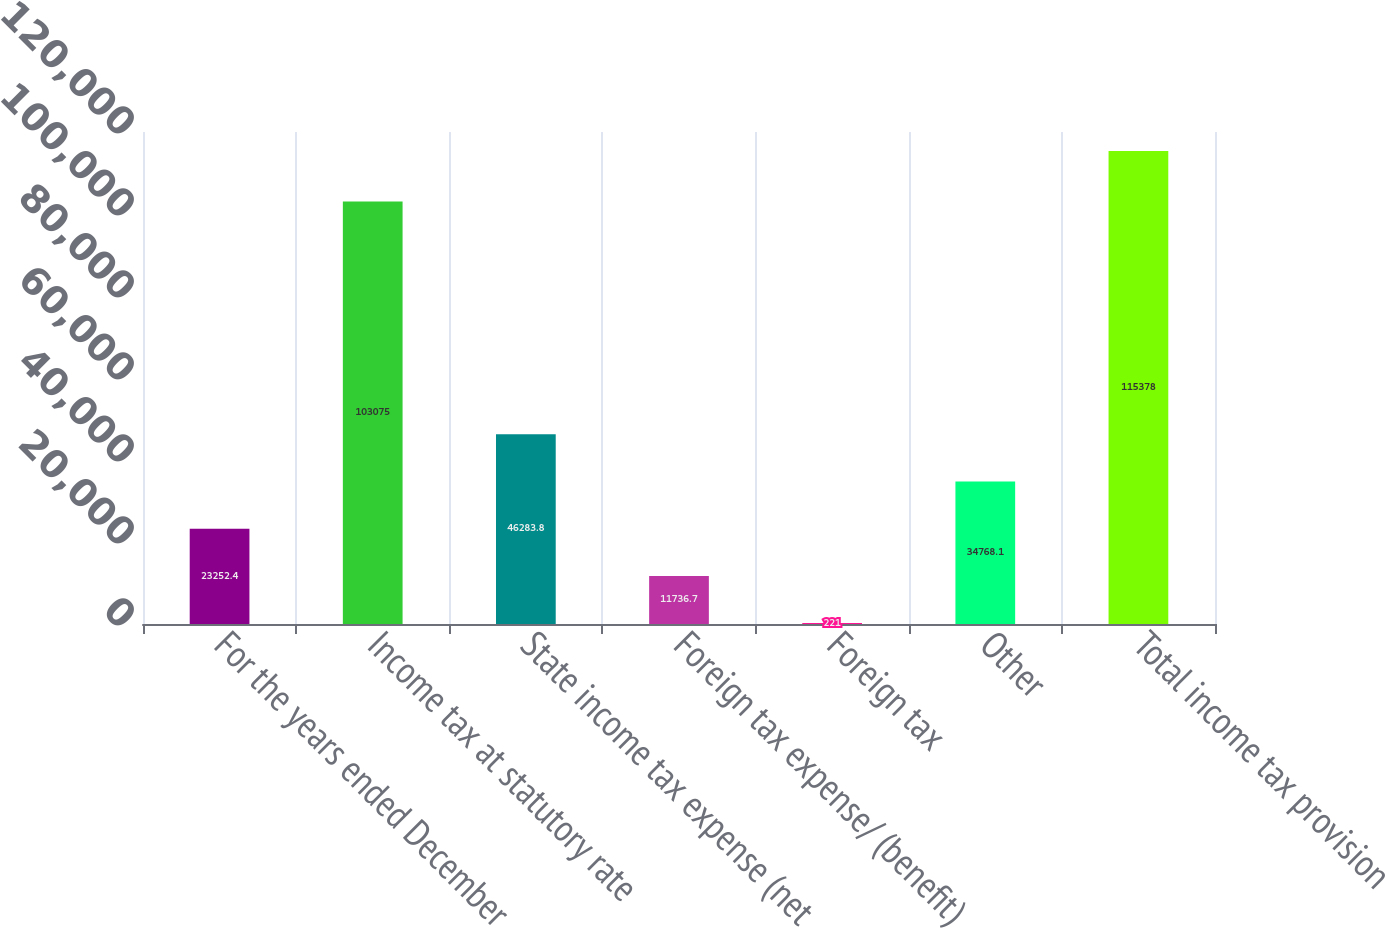<chart> <loc_0><loc_0><loc_500><loc_500><bar_chart><fcel>For the years ended December<fcel>Income tax at statutory rate<fcel>State income tax expense (net<fcel>Foreign tax expense/ (benefit)<fcel>Foreign tax<fcel>Other<fcel>Total income tax provision<nl><fcel>23252.4<fcel>103075<fcel>46283.8<fcel>11736.7<fcel>221<fcel>34768.1<fcel>115378<nl></chart> 